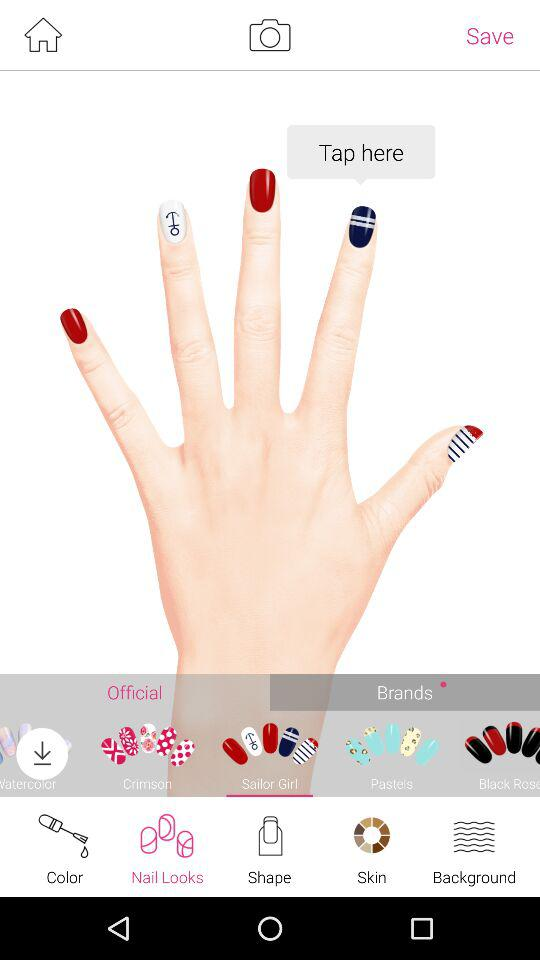Which tab is selected? The selected tabs are "Nail Looks", "Sailor Girl" and "Brands". 